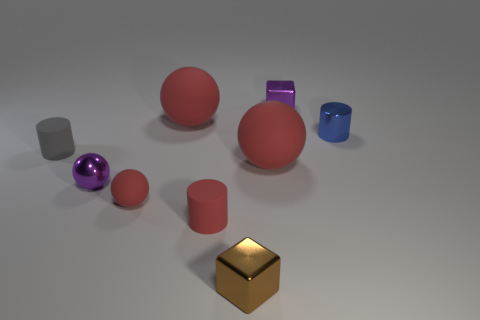How many things are both right of the tiny purple metal cube and left of the tiny blue shiny cylinder?
Make the answer very short. 0. What is the shape of the tiny rubber object that is the same color as the tiny rubber sphere?
Make the answer very short. Cylinder. What material is the tiny thing that is in front of the purple sphere and to the left of the tiny red rubber cylinder?
Make the answer very short. Rubber. Is the number of tiny brown metal cubes behind the small blue metallic cylinder less than the number of gray rubber cylinders in front of the small brown thing?
Your answer should be very brief. No. The purple ball that is the same material as the brown object is what size?
Offer a very short reply. Small. Are there any other things that are the same color as the tiny shiny cylinder?
Your answer should be compact. No. Does the blue cylinder have the same material as the tiny object that is behind the blue metal cylinder?
Offer a terse response. Yes. What is the material of the small red object that is the same shape as the tiny blue thing?
Keep it short and to the point. Rubber. Is there anything else that is made of the same material as the blue object?
Your answer should be compact. Yes. Is the material of the tiny blue object that is behind the small brown metallic object the same as the block that is behind the brown shiny block?
Ensure brevity in your answer.  Yes. 